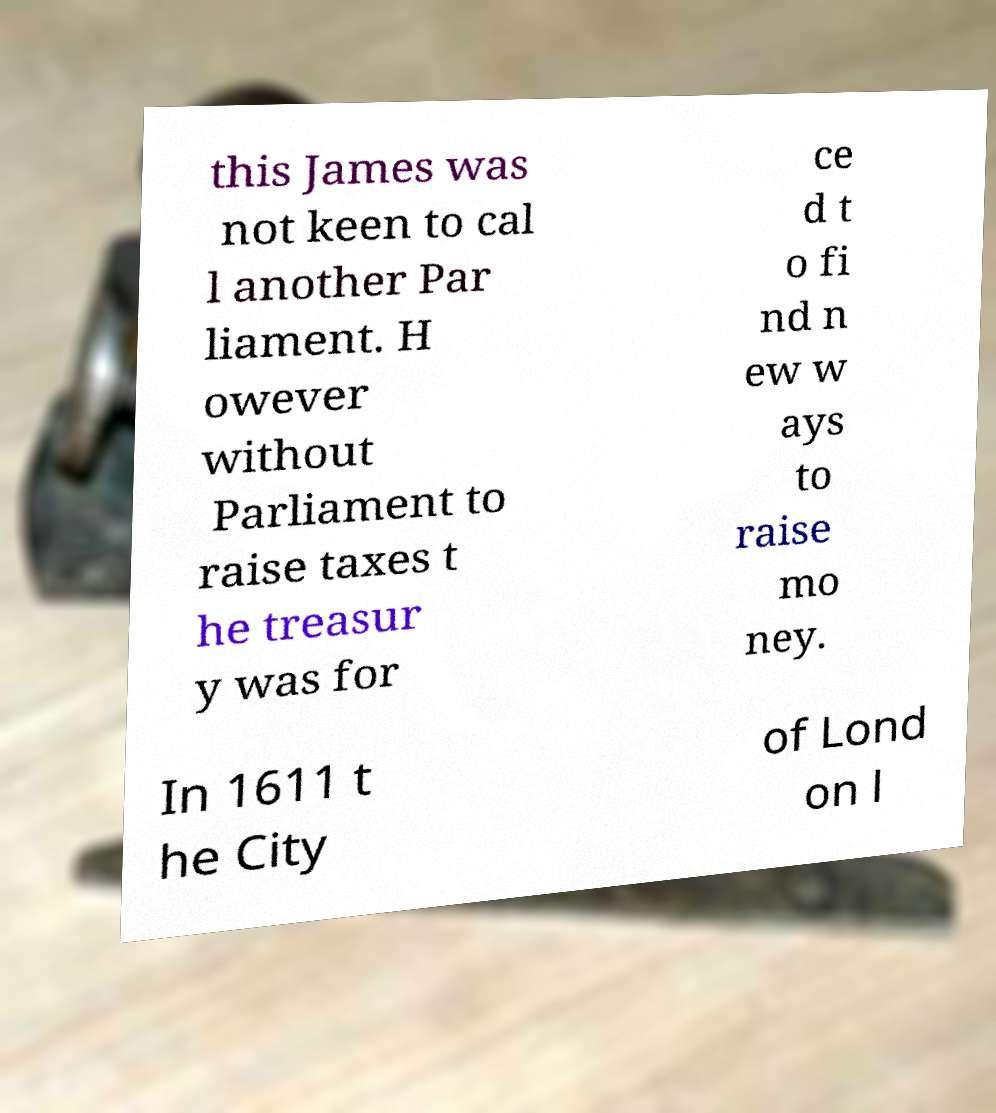Could you extract and type out the text from this image? this James was not keen to cal l another Par liament. H owever without Parliament to raise taxes t he treasur y was for ce d t o fi nd n ew w ays to raise mo ney. In 1611 t he City of Lond on l 